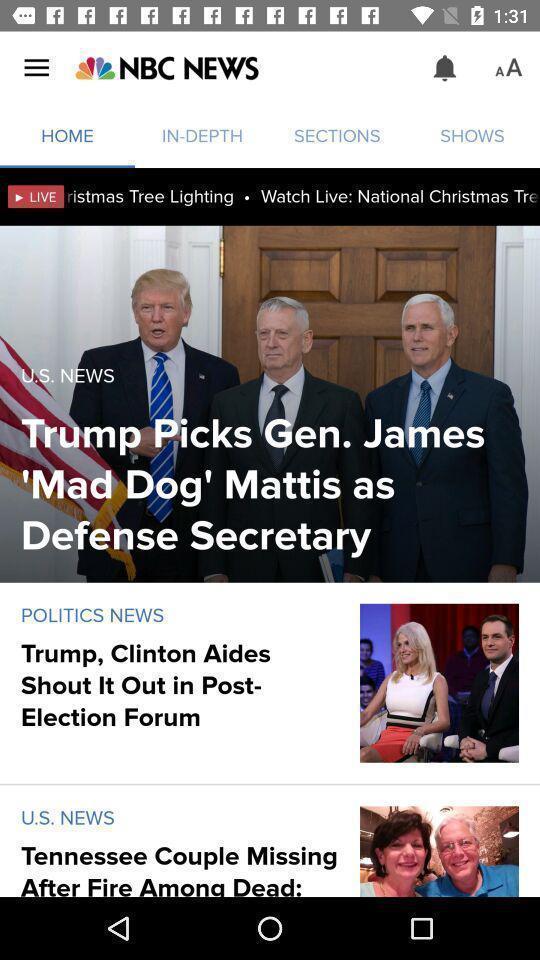Summarize the main components in this picture. Results for home in an news application. 